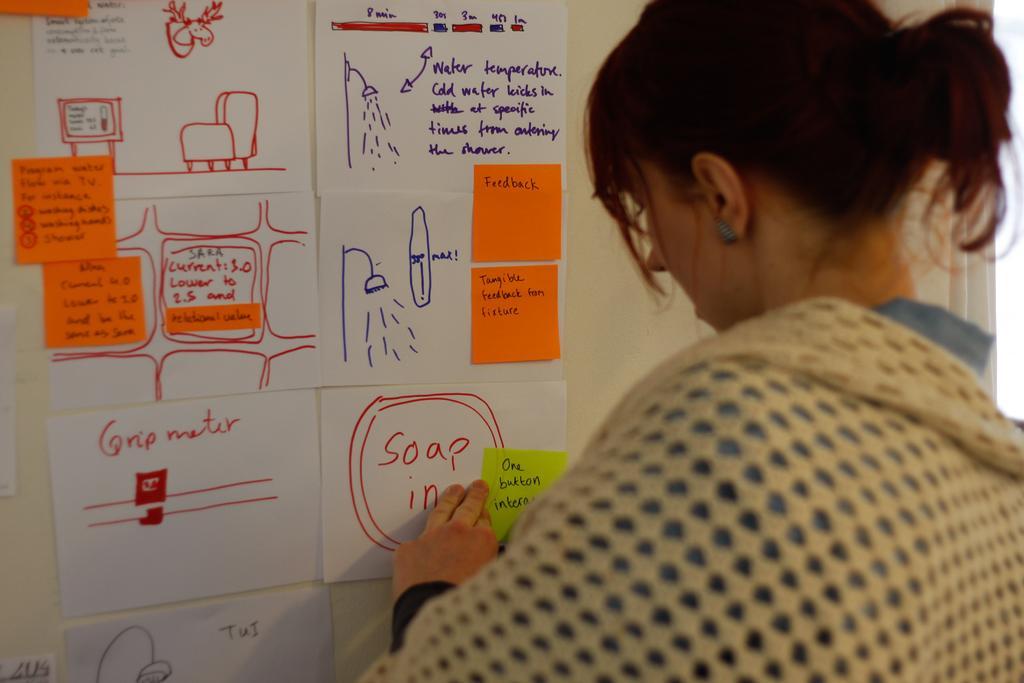Please provide a concise description of this image. In this image in front there is a person sticking the paper on the wall. 